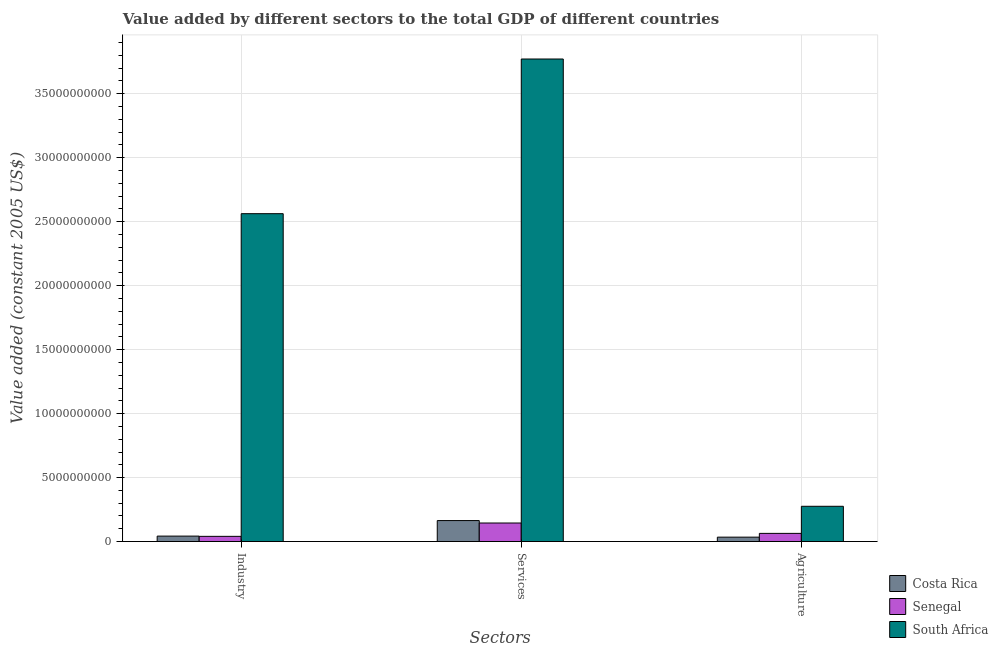How many different coloured bars are there?
Ensure brevity in your answer.  3. How many groups of bars are there?
Provide a succinct answer. 3. Are the number of bars on each tick of the X-axis equal?
Your answer should be very brief. Yes. How many bars are there on the 3rd tick from the left?
Your response must be concise. 3. What is the label of the 3rd group of bars from the left?
Make the answer very short. Agriculture. What is the value added by services in South Africa?
Your answer should be very brief. 3.77e+1. Across all countries, what is the maximum value added by services?
Offer a very short reply. 3.77e+1. Across all countries, what is the minimum value added by services?
Give a very brief answer. 1.45e+09. In which country was the value added by agricultural sector maximum?
Ensure brevity in your answer.  South Africa. In which country was the value added by services minimum?
Provide a succinct answer. Senegal. What is the total value added by agricultural sector in the graph?
Keep it short and to the point. 3.74e+09. What is the difference between the value added by industrial sector in South Africa and that in Costa Rica?
Offer a terse response. 2.52e+1. What is the difference between the value added by services in Senegal and the value added by agricultural sector in South Africa?
Provide a short and direct response. -1.31e+09. What is the average value added by industrial sector per country?
Your response must be concise. 8.82e+09. What is the difference between the value added by industrial sector and value added by agricultural sector in Costa Rica?
Make the answer very short. 8.25e+07. In how many countries, is the value added by agricultural sector greater than 9000000000 US$?
Make the answer very short. 0. What is the ratio of the value added by industrial sector in Costa Rica to that in Senegal?
Your answer should be very brief. 1.05. Is the value added by industrial sector in Senegal less than that in South Africa?
Your response must be concise. Yes. What is the difference between the highest and the second highest value added by agricultural sector?
Your response must be concise. 2.12e+09. What is the difference between the highest and the lowest value added by services?
Your answer should be compact. 3.63e+1. Is the sum of the value added by services in Costa Rica and South Africa greater than the maximum value added by industrial sector across all countries?
Ensure brevity in your answer.  Yes. What does the 2nd bar from the left in Services represents?
Your response must be concise. Senegal. What does the 3rd bar from the right in Agriculture represents?
Ensure brevity in your answer.  Costa Rica. How many countries are there in the graph?
Your response must be concise. 3. Are the values on the major ticks of Y-axis written in scientific E-notation?
Give a very brief answer. No. Does the graph contain any zero values?
Offer a very short reply. No. Where does the legend appear in the graph?
Keep it short and to the point. Bottom right. What is the title of the graph?
Give a very brief answer. Value added by different sectors to the total GDP of different countries. Does "High income: OECD" appear as one of the legend labels in the graph?
Your answer should be very brief. No. What is the label or title of the X-axis?
Your answer should be compact. Sectors. What is the label or title of the Y-axis?
Provide a succinct answer. Value added (constant 2005 US$). What is the Value added (constant 2005 US$) of Costa Rica in Industry?
Offer a terse response. 4.27e+08. What is the Value added (constant 2005 US$) of Senegal in Industry?
Keep it short and to the point. 4.08e+08. What is the Value added (constant 2005 US$) in South Africa in Industry?
Your answer should be compact. 2.56e+1. What is the Value added (constant 2005 US$) of Costa Rica in Services?
Your response must be concise. 1.64e+09. What is the Value added (constant 2005 US$) in Senegal in Services?
Ensure brevity in your answer.  1.45e+09. What is the Value added (constant 2005 US$) of South Africa in Services?
Provide a succinct answer. 3.77e+1. What is the Value added (constant 2005 US$) of Costa Rica in Agriculture?
Provide a succinct answer. 3.44e+08. What is the Value added (constant 2005 US$) in Senegal in Agriculture?
Your answer should be very brief. 6.40e+08. What is the Value added (constant 2005 US$) in South Africa in Agriculture?
Your response must be concise. 2.76e+09. Across all Sectors, what is the maximum Value added (constant 2005 US$) in Costa Rica?
Provide a succinct answer. 1.64e+09. Across all Sectors, what is the maximum Value added (constant 2005 US$) in Senegal?
Your answer should be compact. 1.45e+09. Across all Sectors, what is the maximum Value added (constant 2005 US$) of South Africa?
Give a very brief answer. 3.77e+1. Across all Sectors, what is the minimum Value added (constant 2005 US$) in Costa Rica?
Your answer should be compact. 3.44e+08. Across all Sectors, what is the minimum Value added (constant 2005 US$) in Senegal?
Your response must be concise. 4.08e+08. Across all Sectors, what is the minimum Value added (constant 2005 US$) of South Africa?
Provide a short and direct response. 2.76e+09. What is the total Value added (constant 2005 US$) in Costa Rica in the graph?
Offer a terse response. 2.41e+09. What is the total Value added (constant 2005 US$) of Senegal in the graph?
Provide a short and direct response. 2.50e+09. What is the total Value added (constant 2005 US$) of South Africa in the graph?
Offer a very short reply. 6.61e+1. What is the difference between the Value added (constant 2005 US$) of Costa Rica in Industry and that in Services?
Your answer should be compact. -1.21e+09. What is the difference between the Value added (constant 2005 US$) in Senegal in Industry and that in Services?
Ensure brevity in your answer.  -1.04e+09. What is the difference between the Value added (constant 2005 US$) in South Africa in Industry and that in Services?
Offer a terse response. -1.21e+1. What is the difference between the Value added (constant 2005 US$) in Costa Rica in Industry and that in Agriculture?
Offer a very short reply. 8.25e+07. What is the difference between the Value added (constant 2005 US$) in Senegal in Industry and that in Agriculture?
Offer a very short reply. -2.32e+08. What is the difference between the Value added (constant 2005 US$) in South Africa in Industry and that in Agriculture?
Your answer should be very brief. 2.29e+1. What is the difference between the Value added (constant 2005 US$) in Costa Rica in Services and that in Agriculture?
Your response must be concise. 1.30e+09. What is the difference between the Value added (constant 2005 US$) in Senegal in Services and that in Agriculture?
Give a very brief answer. 8.10e+08. What is the difference between the Value added (constant 2005 US$) of South Africa in Services and that in Agriculture?
Offer a terse response. 3.50e+1. What is the difference between the Value added (constant 2005 US$) of Costa Rica in Industry and the Value added (constant 2005 US$) of Senegal in Services?
Provide a short and direct response. -1.02e+09. What is the difference between the Value added (constant 2005 US$) in Costa Rica in Industry and the Value added (constant 2005 US$) in South Africa in Services?
Your response must be concise. -3.73e+1. What is the difference between the Value added (constant 2005 US$) in Senegal in Industry and the Value added (constant 2005 US$) in South Africa in Services?
Your response must be concise. -3.73e+1. What is the difference between the Value added (constant 2005 US$) of Costa Rica in Industry and the Value added (constant 2005 US$) of Senegal in Agriculture?
Provide a succinct answer. -2.13e+08. What is the difference between the Value added (constant 2005 US$) of Costa Rica in Industry and the Value added (constant 2005 US$) of South Africa in Agriculture?
Give a very brief answer. -2.33e+09. What is the difference between the Value added (constant 2005 US$) in Senegal in Industry and the Value added (constant 2005 US$) in South Africa in Agriculture?
Make the answer very short. -2.35e+09. What is the difference between the Value added (constant 2005 US$) of Costa Rica in Services and the Value added (constant 2005 US$) of Senegal in Agriculture?
Ensure brevity in your answer.  1.00e+09. What is the difference between the Value added (constant 2005 US$) of Costa Rica in Services and the Value added (constant 2005 US$) of South Africa in Agriculture?
Ensure brevity in your answer.  -1.12e+09. What is the difference between the Value added (constant 2005 US$) of Senegal in Services and the Value added (constant 2005 US$) of South Africa in Agriculture?
Offer a terse response. -1.31e+09. What is the average Value added (constant 2005 US$) of Costa Rica per Sectors?
Keep it short and to the point. 8.04e+08. What is the average Value added (constant 2005 US$) of Senegal per Sectors?
Provide a short and direct response. 8.32e+08. What is the average Value added (constant 2005 US$) of South Africa per Sectors?
Your response must be concise. 2.20e+1. What is the difference between the Value added (constant 2005 US$) of Costa Rica and Value added (constant 2005 US$) of Senegal in Industry?
Your response must be concise. 1.93e+07. What is the difference between the Value added (constant 2005 US$) in Costa Rica and Value added (constant 2005 US$) in South Africa in Industry?
Your answer should be compact. -2.52e+1. What is the difference between the Value added (constant 2005 US$) of Senegal and Value added (constant 2005 US$) of South Africa in Industry?
Give a very brief answer. -2.52e+1. What is the difference between the Value added (constant 2005 US$) of Costa Rica and Value added (constant 2005 US$) of Senegal in Services?
Provide a short and direct response. 1.91e+08. What is the difference between the Value added (constant 2005 US$) in Costa Rica and Value added (constant 2005 US$) in South Africa in Services?
Keep it short and to the point. -3.61e+1. What is the difference between the Value added (constant 2005 US$) in Senegal and Value added (constant 2005 US$) in South Africa in Services?
Your answer should be compact. -3.63e+1. What is the difference between the Value added (constant 2005 US$) of Costa Rica and Value added (constant 2005 US$) of Senegal in Agriculture?
Give a very brief answer. -2.95e+08. What is the difference between the Value added (constant 2005 US$) of Costa Rica and Value added (constant 2005 US$) of South Africa in Agriculture?
Give a very brief answer. -2.41e+09. What is the difference between the Value added (constant 2005 US$) of Senegal and Value added (constant 2005 US$) of South Africa in Agriculture?
Offer a terse response. -2.12e+09. What is the ratio of the Value added (constant 2005 US$) in Costa Rica in Industry to that in Services?
Keep it short and to the point. 0.26. What is the ratio of the Value added (constant 2005 US$) in Senegal in Industry to that in Services?
Offer a terse response. 0.28. What is the ratio of the Value added (constant 2005 US$) in South Africa in Industry to that in Services?
Provide a short and direct response. 0.68. What is the ratio of the Value added (constant 2005 US$) in Costa Rica in Industry to that in Agriculture?
Your response must be concise. 1.24. What is the ratio of the Value added (constant 2005 US$) of Senegal in Industry to that in Agriculture?
Your response must be concise. 0.64. What is the ratio of the Value added (constant 2005 US$) of South Africa in Industry to that in Agriculture?
Keep it short and to the point. 9.3. What is the ratio of the Value added (constant 2005 US$) in Costa Rica in Services to that in Agriculture?
Keep it short and to the point. 4.77. What is the ratio of the Value added (constant 2005 US$) in Senegal in Services to that in Agriculture?
Your response must be concise. 2.27. What is the ratio of the Value added (constant 2005 US$) in South Africa in Services to that in Agriculture?
Ensure brevity in your answer.  13.68. What is the difference between the highest and the second highest Value added (constant 2005 US$) in Costa Rica?
Keep it short and to the point. 1.21e+09. What is the difference between the highest and the second highest Value added (constant 2005 US$) in Senegal?
Give a very brief answer. 8.10e+08. What is the difference between the highest and the second highest Value added (constant 2005 US$) in South Africa?
Keep it short and to the point. 1.21e+1. What is the difference between the highest and the lowest Value added (constant 2005 US$) of Costa Rica?
Your answer should be very brief. 1.30e+09. What is the difference between the highest and the lowest Value added (constant 2005 US$) of Senegal?
Provide a succinct answer. 1.04e+09. What is the difference between the highest and the lowest Value added (constant 2005 US$) of South Africa?
Keep it short and to the point. 3.50e+1. 